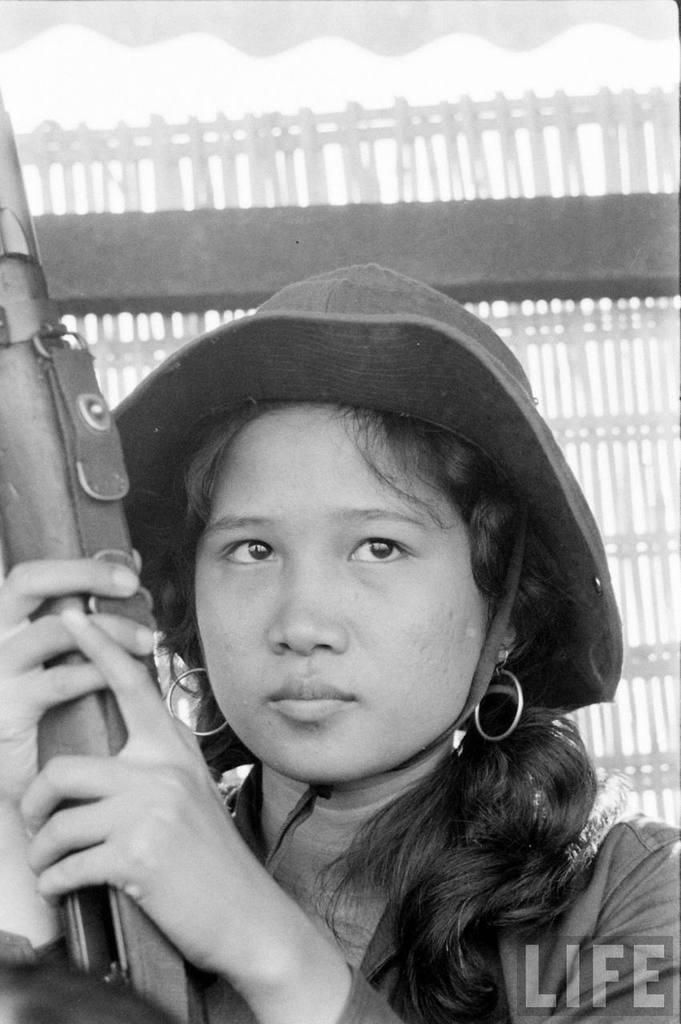Please provide a concise description of this image. This picture shows a woman seated and holding a gun in her hand and she wore a hat on her hand and we see a watermark on the right bottom. 